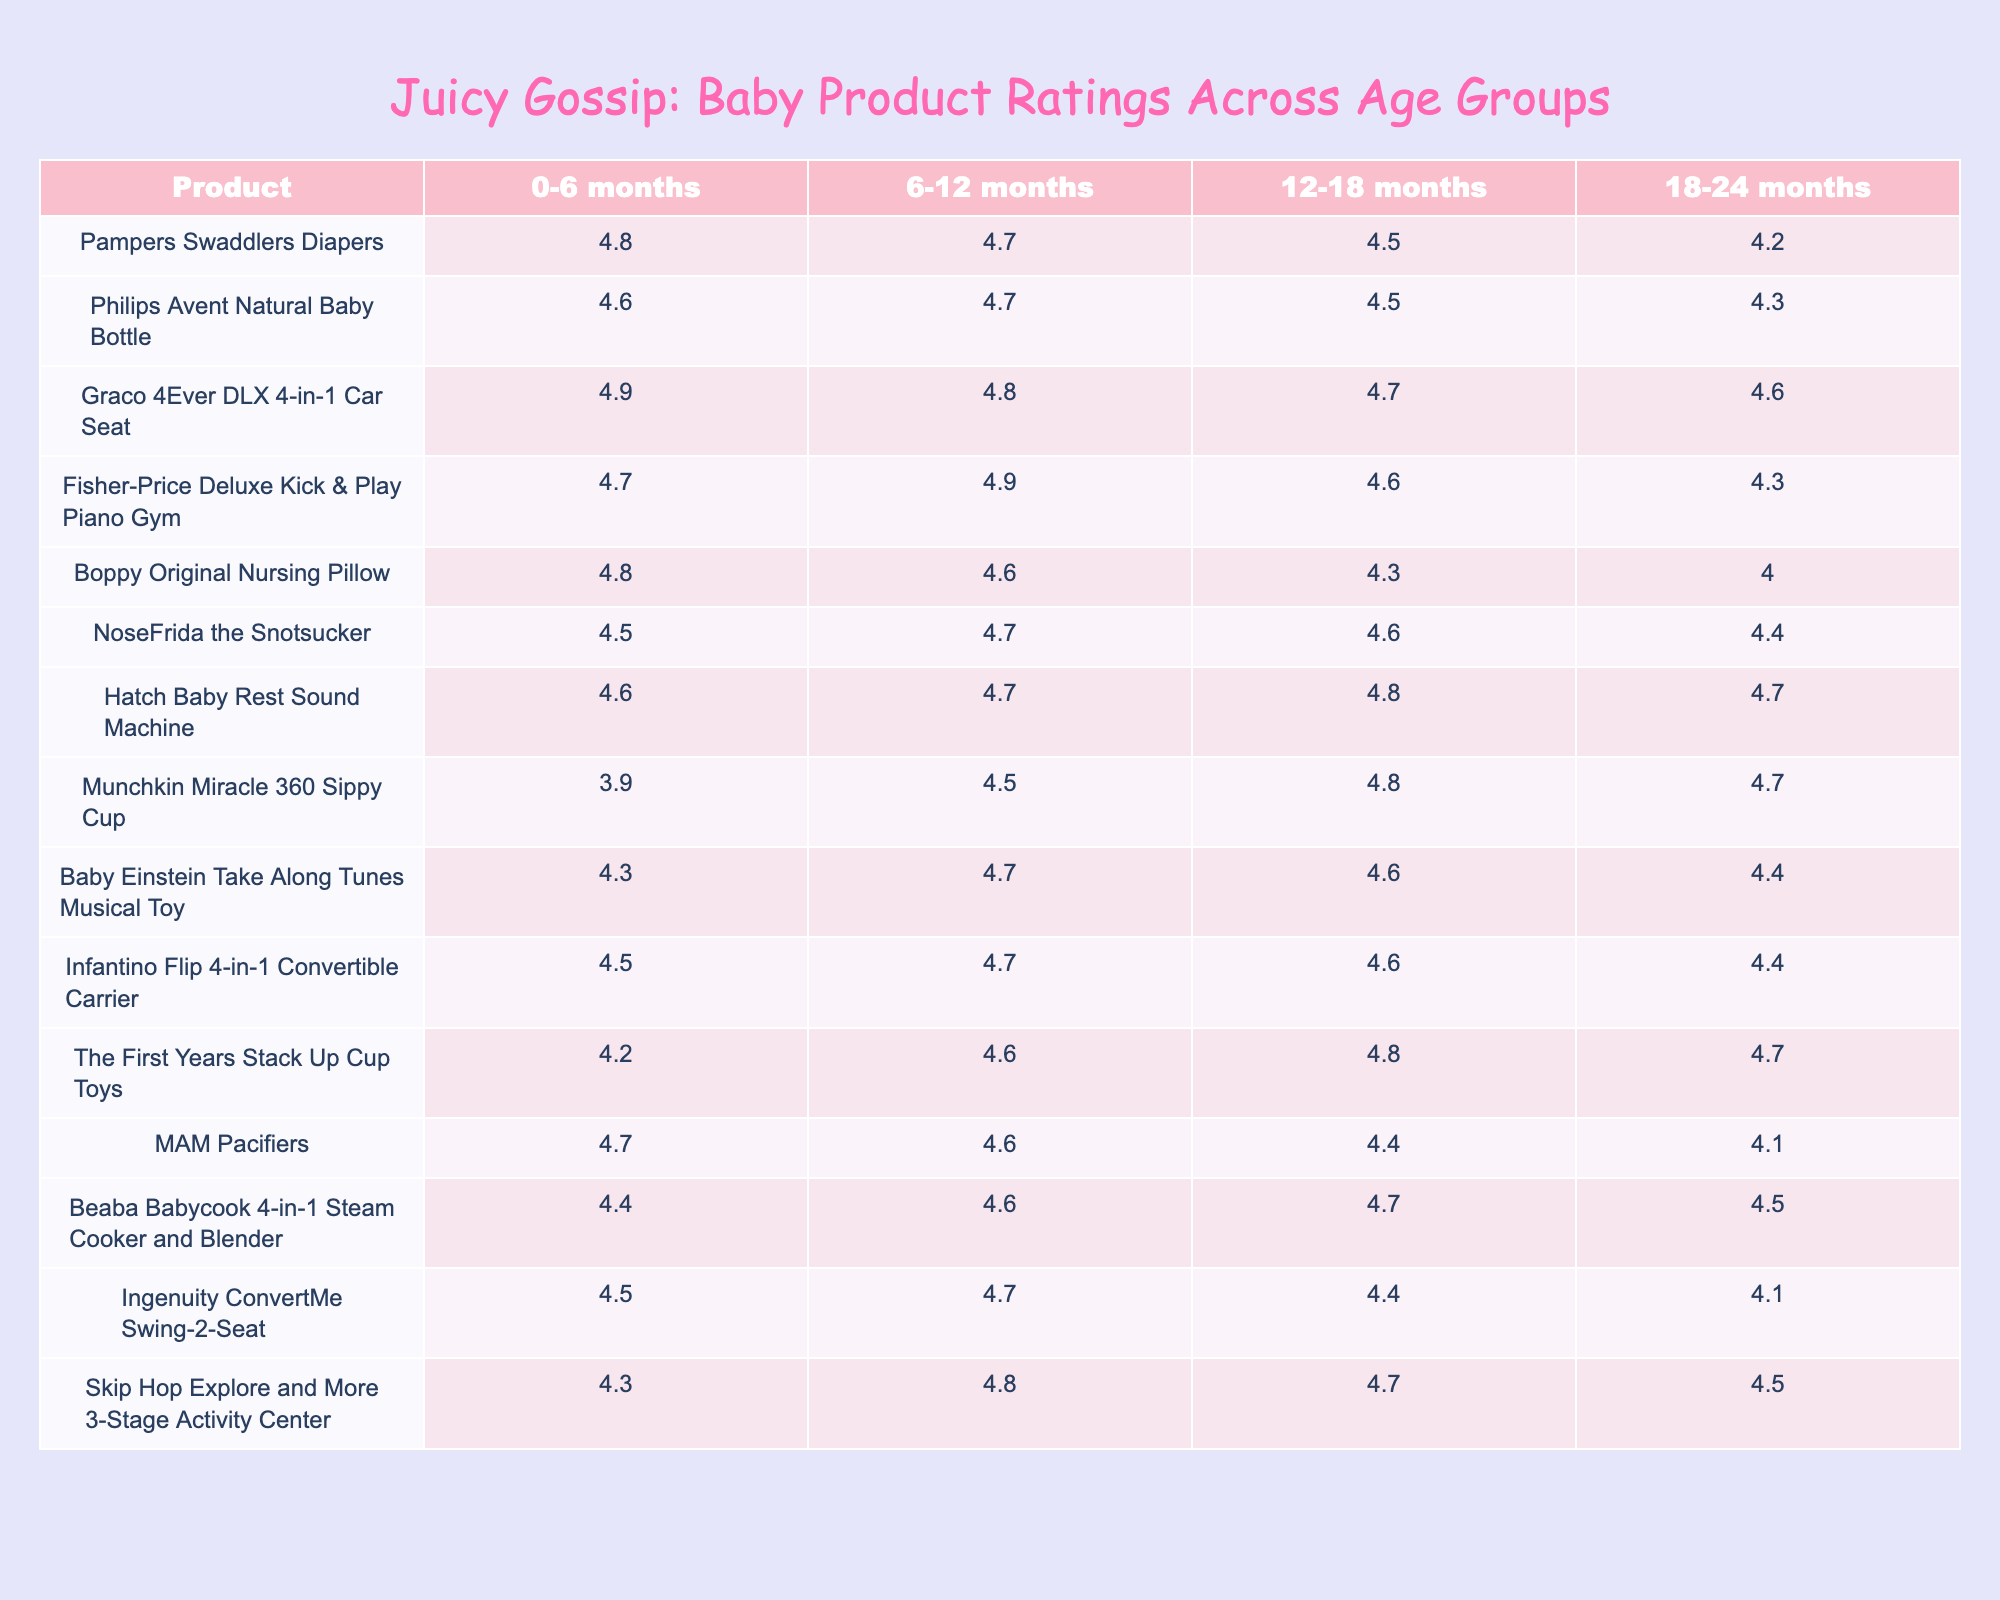What is the highest-rated product for 0-6 months? The highest rating in the 0-6 months category is for the Graco 4Ever DLX 4-in-1 Car Seat, which has a rating of 4.9.
Answer: Graco 4Ever DLX 4-in-1 Car Seat Which product has the lowest rating for 12-18 months? The lowest rating in the 12-18 months category is for Munchkin Miracle 360 Sippy Cup with a rating of 4.8.
Answer: Munchkin Miracle 360 Sippy Cup What is the average rating of the Pampers Swaddlers Diapers across all age groups? To find the average, sum the ratings for all age groups (4.8 + 4.7 + 4.5 + 4.2) = 18.2, and then divide by 4. The average is 18.2 / 4 = 4.55.
Answer: 4.55 Is the Philips Avent Natural Baby Bottle rated higher than the Fisher-Price Deluxe Kick & Play Piano Gym for 18-24 months? For the 18-24 months age group, the Philips Avent Natural Baby Bottle has a rating of 4.3 and the Fisher-Price Deluxe Kick & Play Piano Gym has a rating of 4.3 as well. They are rated the same.
Answer: No Which product shows the biggest rating drop from 0-6 months to 18-24 months? The biggest drop is for the Boppy Original Nursing Pillow, which starts at 4.8 and falls to 4.0, calculating the drop as (4.8 - 4.0) = 0.8.
Answer: Boppy Original Nursing Pillow What is the difference between the ratings of the Graco 4Ever DLX 4-in-1 Car Seat in the 0-6 months and 18-24 months categories? The rating for Graco 4Ever in the 0-6 months is 4.9 and in the 18-24 months it's 4.6. The difference is (4.9 - 4.6) = 0.3.
Answer: 0.3 Which product has a rating of 4.8 or higher in at least three different age groups? The Graco 4Ever DLX 4-in-1 Car Seat (4.9, 4.8, 4.7), and the Fisher-Price Deluxe Kick & Play Piano Gym (4.7, 4.9, 4.6) both meet this criterion, as they have ratings of 4.8 or higher in three categories.
Answer: Graco 4Ever DLX 4-in-1 Car Seat, Fisher-Price Deluxe Kick & Play Piano Gym What percentages of products have a rating of 4.5 or higher across all age groups? There are 9 products with ratings of 4.5 or higher out of a total of 12 products. The percentage is (9/12) * 100 = 75%.
Answer: 75% Which product maintained a consistent rating throughout all age groups? The NoseFrida the Snotsucker shows ratings of 4.5, 4.7, 4.6, and 4.4. The product with the most consistent rating is Baby Einstein Take Along Tunes Musical Toy with ratings 4.3, 4.7, 4.6, 4.4, showing slight variations but overall consistency.
Answer: None, consistent variation Among the products listed, which has the highest decline in ratings from 0-6 months to 18-24 months? The Boppy Original Nursing Pillow shows a decline from 4.8 to 4.0, which calculates to a difference of 0.8, indicating the highest decline.
Answer: Boppy Original Nursing Pillow 